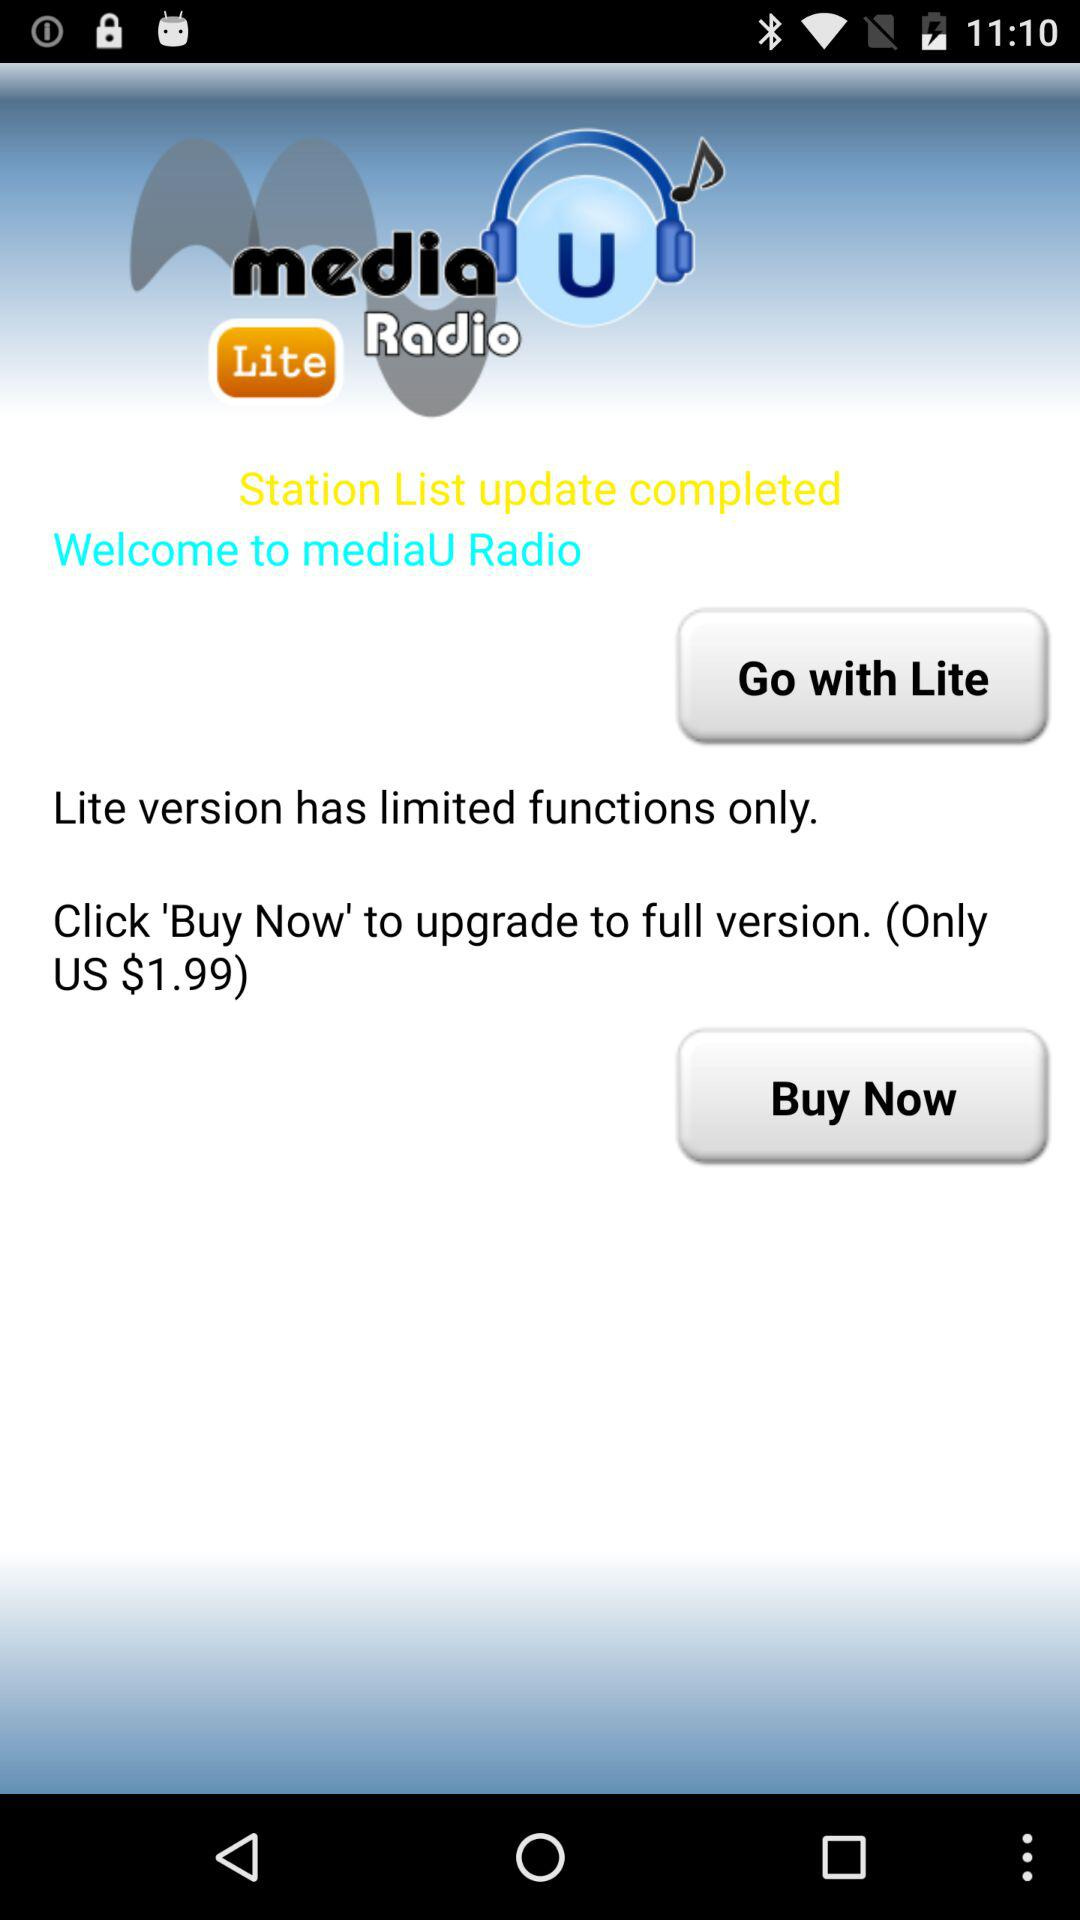How many more dollars does the full version cost than the lite version?
Answer the question using a single word or phrase. 1.99 